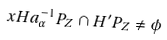<formula> <loc_0><loc_0><loc_500><loc_500>x H a _ { \alpha } ^ { - 1 } P _ { Z } \cap H ^ { \prime } P _ { Z } \ne \phi</formula> 